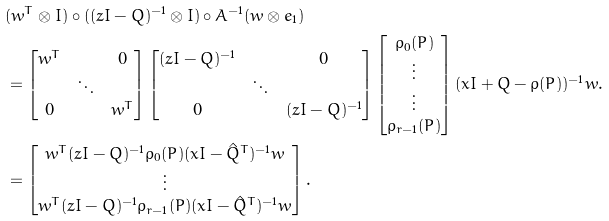<formula> <loc_0><loc_0><loc_500><loc_500>& ( w ^ { T } \otimes I ) \circ ( ( z I - Q ) ^ { - 1 } \otimes I ) \circ A ^ { - 1 } ( w \otimes e _ { 1 } ) \\ & = \left [ \begin{matrix} w ^ { T } & & 0 \\ & \ddots & \\ 0 & & w ^ { T } \end{matrix} \right ] \left [ \begin{matrix} ( z I - Q ) ^ { - 1 } & & 0 \\ & \ddots & \\ 0 & & ( z I - Q ) ^ { - 1 } \end{matrix} \right ] \left [ \begin{matrix} \rho _ { 0 } ( P ) \\ \vdots \\ \vdots \\ \rho _ { r - 1 } ( P ) \end{matrix} \right ] ( x I + Q - \rho ( P ) ) ^ { - 1 } w . \\ & = \left [ \begin{matrix} w ^ { T } ( z I - Q ) ^ { - 1 } \rho _ { 0 } ( P ) ( x I - \hat { Q } ^ { T } ) ^ { - 1 } w \\ \vdots \\ w ^ { T } ( z I - Q ) ^ { - 1 } \rho _ { r - 1 } ( P ) ( x I - \hat { Q } ^ { T } ) ^ { - 1 } w \end{matrix} \right ] .</formula> 